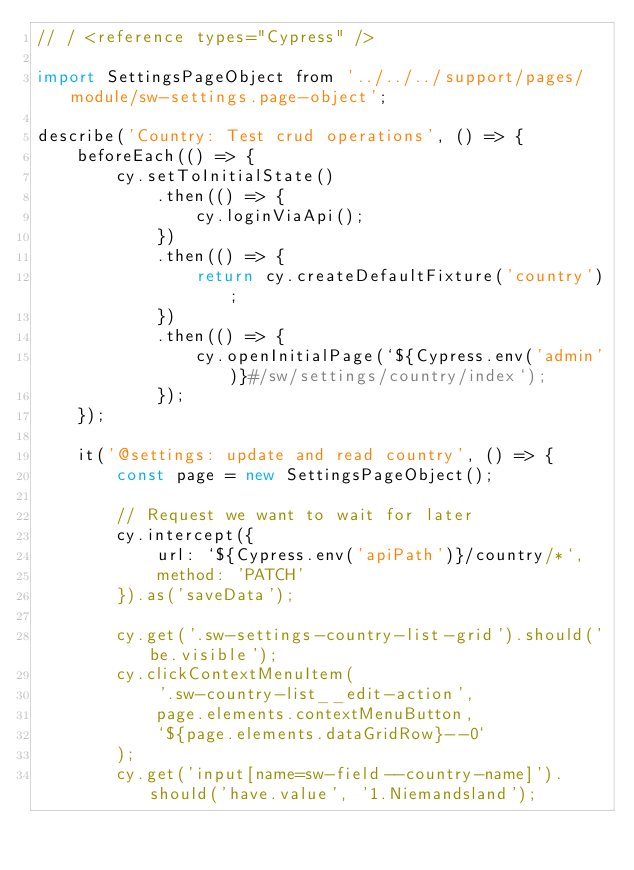Convert code to text. <code><loc_0><loc_0><loc_500><loc_500><_JavaScript_>// / <reference types="Cypress" />

import SettingsPageObject from '../../../support/pages/module/sw-settings.page-object';

describe('Country: Test crud operations', () => {
    beforeEach(() => {
        cy.setToInitialState()
            .then(() => {
                cy.loginViaApi();
            })
            .then(() => {
                return cy.createDefaultFixture('country');
            })
            .then(() => {
                cy.openInitialPage(`${Cypress.env('admin')}#/sw/settings/country/index`);
            });
    });

    it('@settings: update and read country', () => {
        const page = new SettingsPageObject();

        // Request we want to wait for later
        cy.intercept({
            url: `${Cypress.env('apiPath')}/country/*`,
            method: 'PATCH'
        }).as('saveData');

        cy.get('.sw-settings-country-list-grid').should('be.visible');
        cy.clickContextMenuItem(
            '.sw-country-list__edit-action',
            page.elements.contextMenuButton,
            `${page.elements.dataGridRow}--0`
        );
        cy.get('input[name=sw-field--country-name]').should('have.value', '1.Niemandsland');</code> 